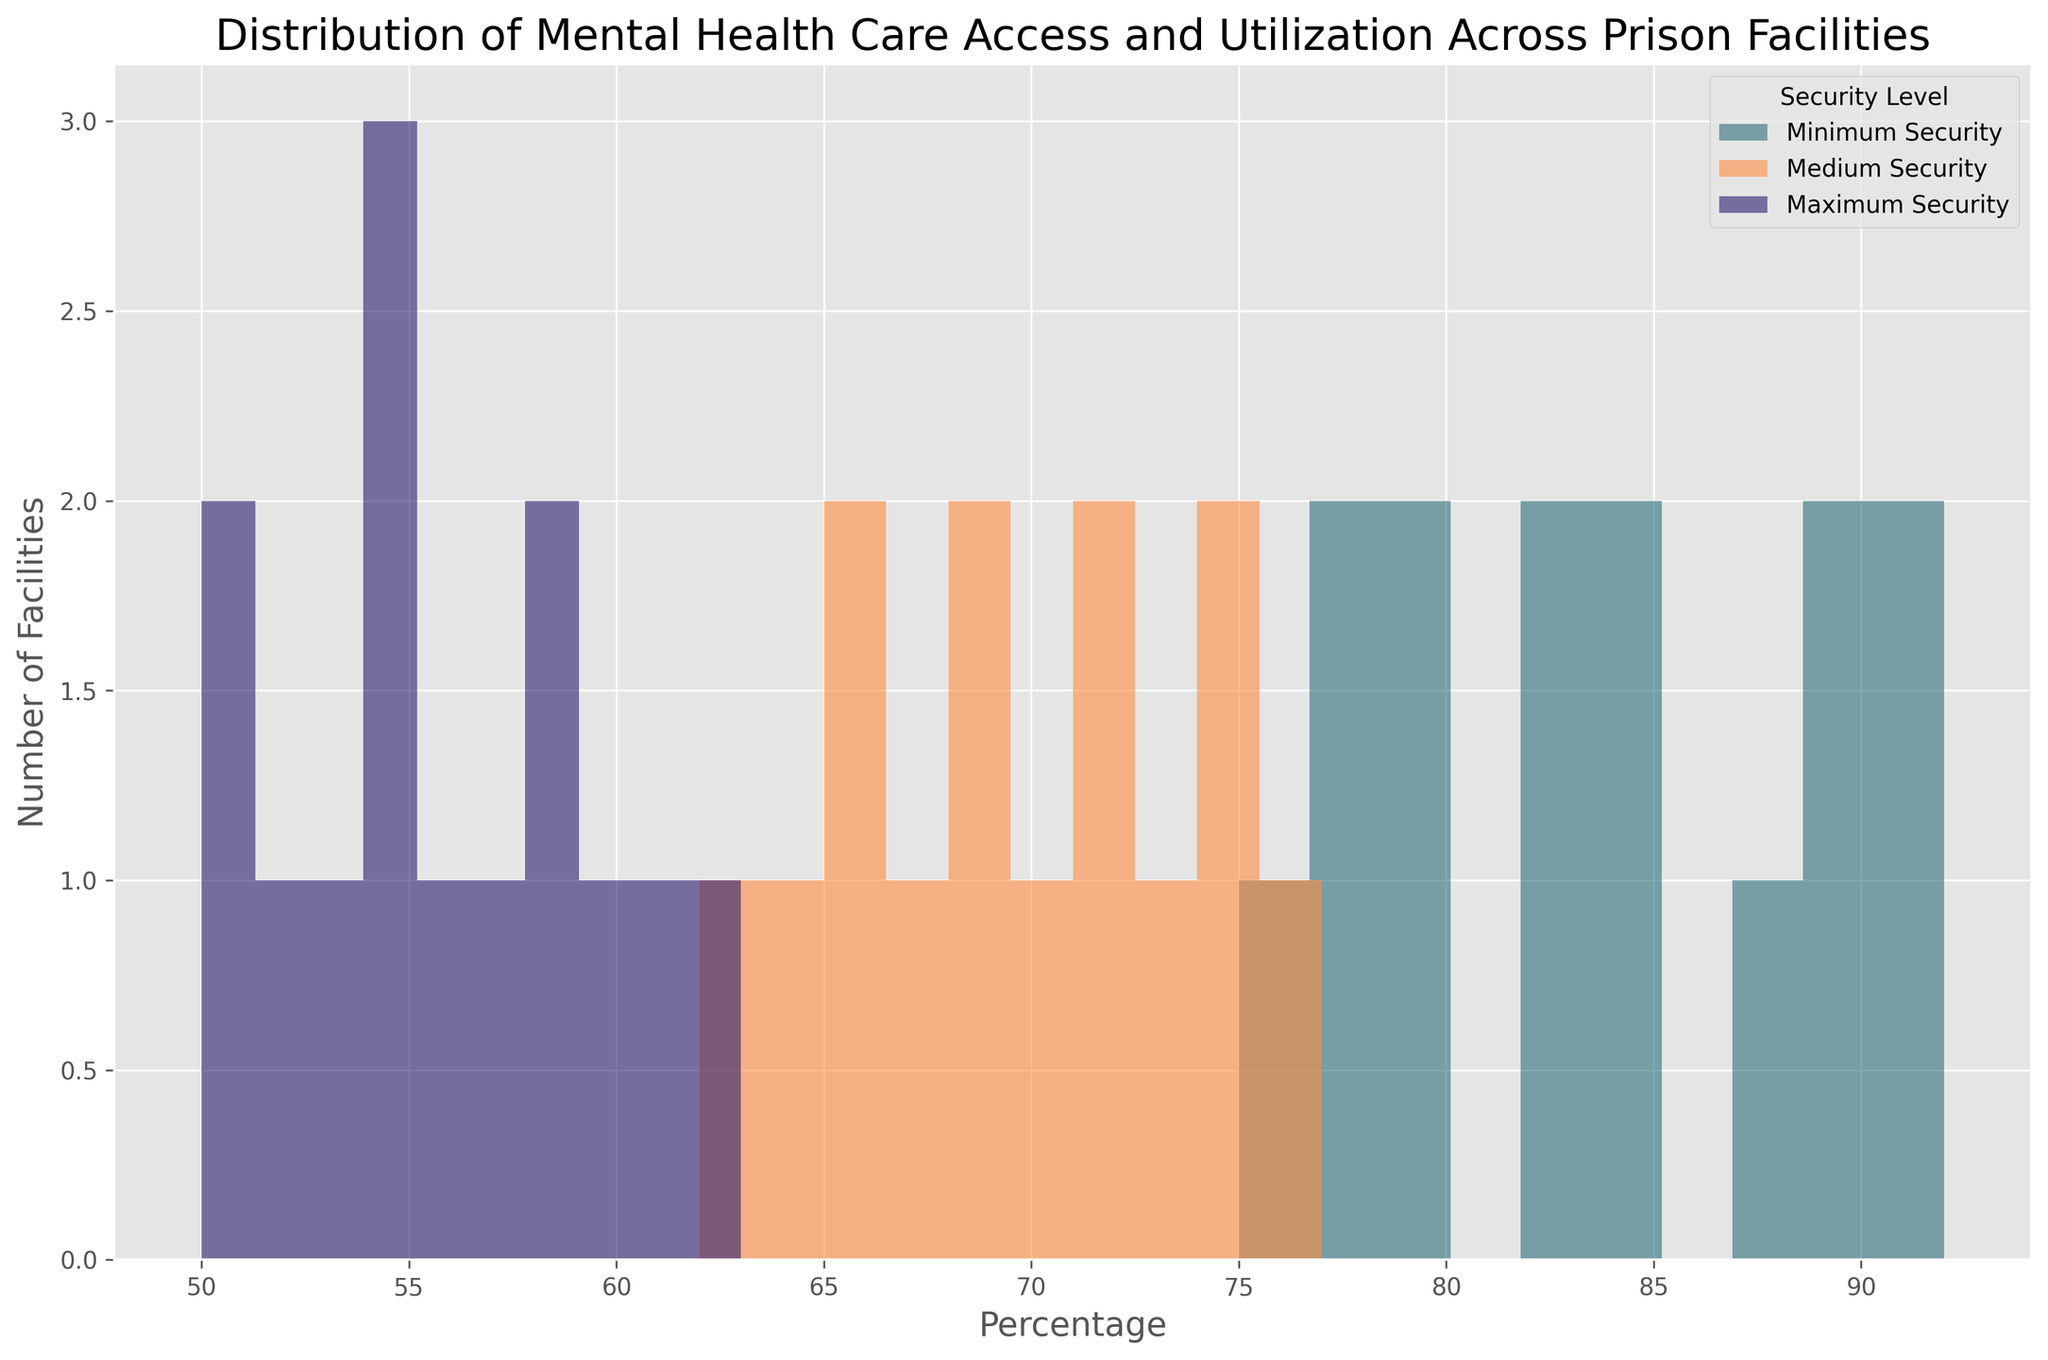What is the range of Mental Health Care Access Percentages for minimum security facilities? To find the range, identify the minimum and maximum values of Mental Health Care Access Percentages for minimum security facilities from the histogram. The minimum value is 75%, and the maximum value is 92%. The range is 92% - 75%.
Answer: 17% Which security level has the highest median Mental Health Care Access Percentage? To find the median, organize the Mental Health Care Access Percentages for each security level and find the middle value. For minimum security: [75, 77, 78, 79, 80, 82, 83, 85, 88, 89, 90, 91, 92]; median = 83. For medium security: [62, 64, 65, 66, 67, 68, 69, 70, 71, 72, 73, 74, 75, 77]; median = 69. For maximum security: [50, 51, 52, 53, 54, 55, 56, 57, 58, 59, 60, 61, 63]; median = 55.
Answer: Minimum security Between medium and maximum security facilities, which has a wider distribution for Utilization Percentage and by how much? Compare the range (maximum - minimum) of Utilization Percentage for each security level. For medium security, the range is 59% - 43% = 16%. For maximum security, the range is 42% - 29% = 13%. The difference in range is 16% - 13%.
Answer: Medium security by 3% Which security level shows the least variance in Mental Health Care Access Percentages? Estimate the spread of the histogram bars. The variance can be observed by checking how tightly clustered the data points are. Visually, maximum security facilities show the least variance, with most percentages close to the center around 57%.
Answer: Maximum security How many minimum security facilities have a Mental Health Care Access Percentage above 80%? Count the number of histogram bars that represent minimum security facilities (typically in a specific color) and whose Mental Health Care Access Percentages are above 80%. Based on the histogram, there are 10 such facilities.
Answer: 10 Is there any overlap in Mental Health Care Access Percentages between medium and maximum security facilities? Check if any percentages for medium security facilities fall within the range of percentages for maximum security facilities and vice versa. Medium security (62% - 77%) and maximum security (50% - 63%) do overlap from 62% to 63%.
Answer: Yes 